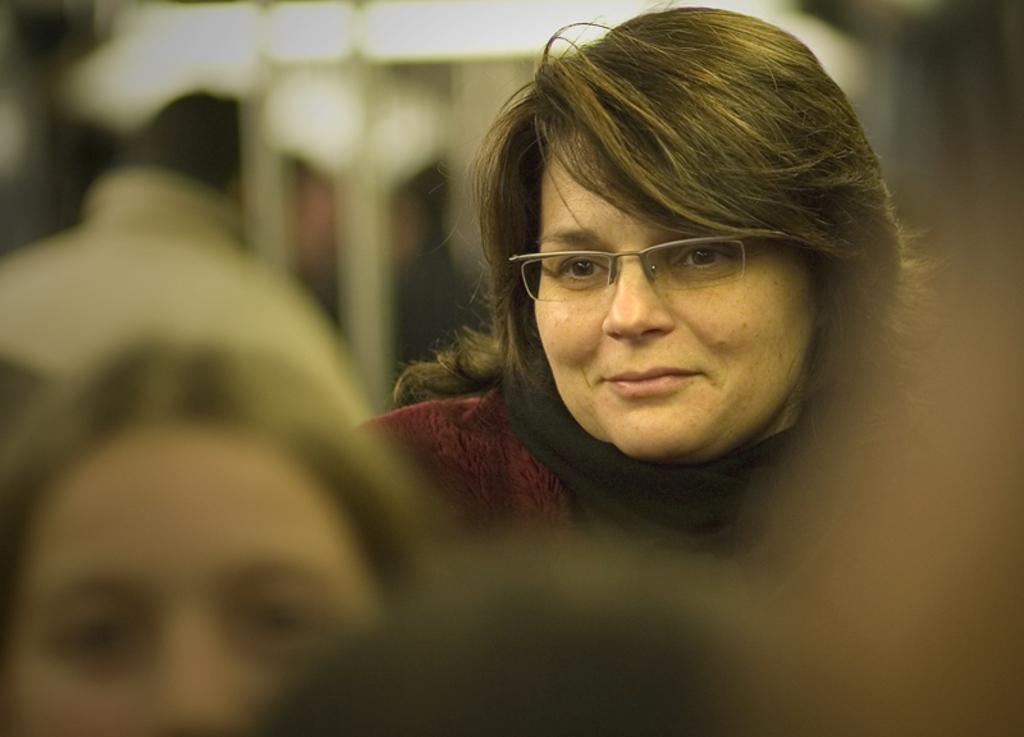What is the person in the image wearing? The person is wearing a maroon color dress in the image. Can you describe any accessories the person is wearing? The person is wearing spectacles. What is the position of the second person in relation to the first person? The second person is standing in front of the first person. How would you describe the background of the image? The background of the image is blurred. What type of rock can be seen in the person's hand in the image? There is no rock present in the person's hand or in the image. 